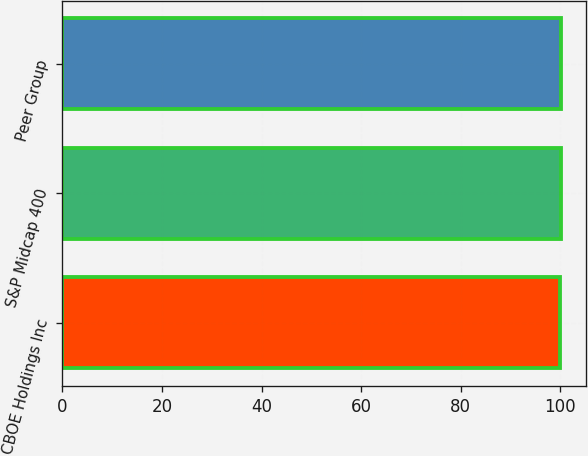<chart> <loc_0><loc_0><loc_500><loc_500><bar_chart><fcel>CBOE Holdings Inc<fcel>S&P Midcap 400<fcel>Peer Group<nl><fcel>100<fcel>100.1<fcel>100.2<nl></chart> 